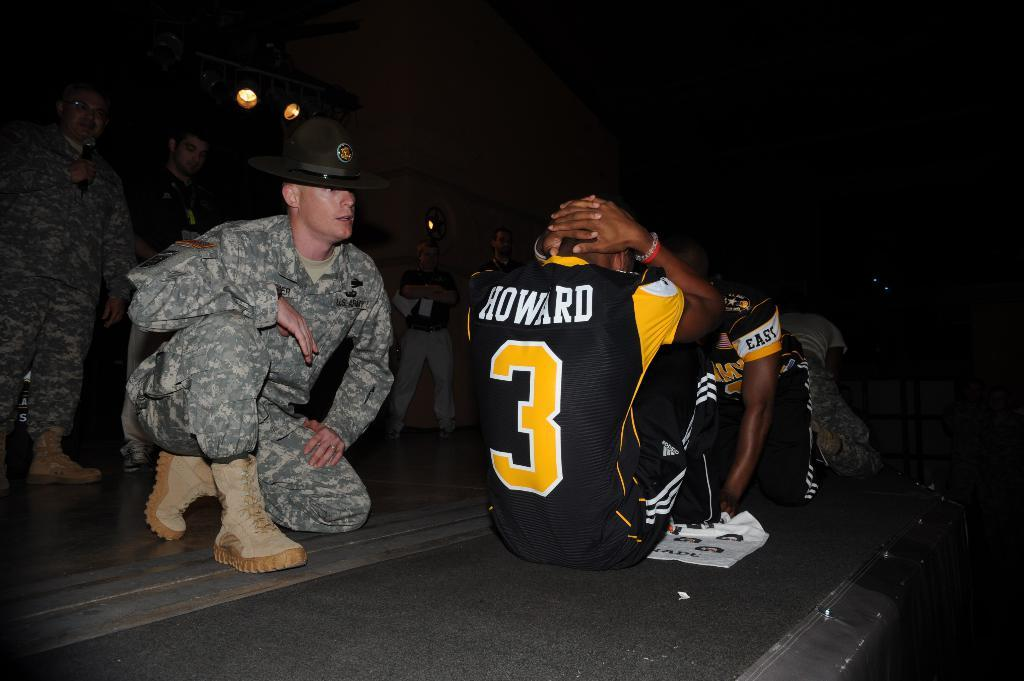<image>
Create a compact narrative representing the image presented. a person that has the number 3 on them 